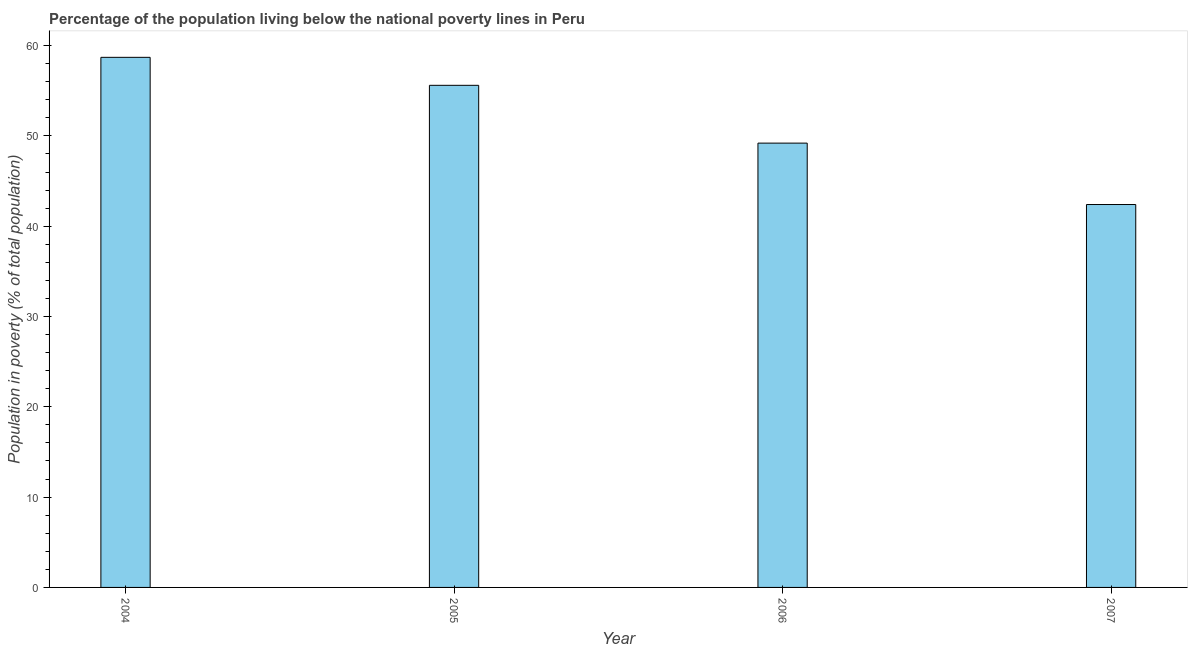Does the graph contain any zero values?
Your response must be concise. No. Does the graph contain grids?
Provide a succinct answer. No. What is the title of the graph?
Your answer should be compact. Percentage of the population living below the national poverty lines in Peru. What is the label or title of the Y-axis?
Give a very brief answer. Population in poverty (% of total population). What is the percentage of population living below poverty line in 2006?
Offer a very short reply. 49.2. Across all years, what is the maximum percentage of population living below poverty line?
Your answer should be compact. 58.7. Across all years, what is the minimum percentage of population living below poverty line?
Ensure brevity in your answer.  42.4. What is the sum of the percentage of population living below poverty line?
Make the answer very short. 205.9. What is the difference between the percentage of population living below poverty line in 2004 and 2006?
Offer a terse response. 9.5. What is the average percentage of population living below poverty line per year?
Keep it short and to the point. 51.48. What is the median percentage of population living below poverty line?
Offer a very short reply. 52.4. What is the ratio of the percentage of population living below poverty line in 2004 to that in 2006?
Your response must be concise. 1.19. Is the percentage of population living below poverty line in 2006 less than that in 2007?
Offer a terse response. No. What is the difference between the highest and the second highest percentage of population living below poverty line?
Your response must be concise. 3.1. In how many years, is the percentage of population living below poverty line greater than the average percentage of population living below poverty line taken over all years?
Give a very brief answer. 2. What is the difference between two consecutive major ticks on the Y-axis?
Your answer should be compact. 10. What is the Population in poverty (% of total population) in 2004?
Provide a succinct answer. 58.7. What is the Population in poverty (% of total population) in 2005?
Provide a short and direct response. 55.6. What is the Population in poverty (% of total population) of 2006?
Your answer should be compact. 49.2. What is the Population in poverty (% of total population) of 2007?
Your response must be concise. 42.4. What is the difference between the Population in poverty (% of total population) in 2004 and 2007?
Make the answer very short. 16.3. What is the difference between the Population in poverty (% of total population) in 2006 and 2007?
Your response must be concise. 6.8. What is the ratio of the Population in poverty (% of total population) in 2004 to that in 2005?
Offer a terse response. 1.06. What is the ratio of the Population in poverty (% of total population) in 2004 to that in 2006?
Offer a terse response. 1.19. What is the ratio of the Population in poverty (% of total population) in 2004 to that in 2007?
Give a very brief answer. 1.38. What is the ratio of the Population in poverty (% of total population) in 2005 to that in 2006?
Ensure brevity in your answer.  1.13. What is the ratio of the Population in poverty (% of total population) in 2005 to that in 2007?
Your answer should be compact. 1.31. What is the ratio of the Population in poverty (% of total population) in 2006 to that in 2007?
Keep it short and to the point. 1.16. 